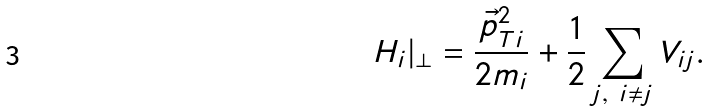Convert formula to latex. <formula><loc_0><loc_0><loc_500><loc_500>H _ { i } | _ { \perp } = \frac { \vec { p } _ { T i } ^ { 2 } } { 2 m _ { i } } + \frac { 1 } { 2 } \sum _ { j , \ i \neq j } V _ { i j } .</formula> 